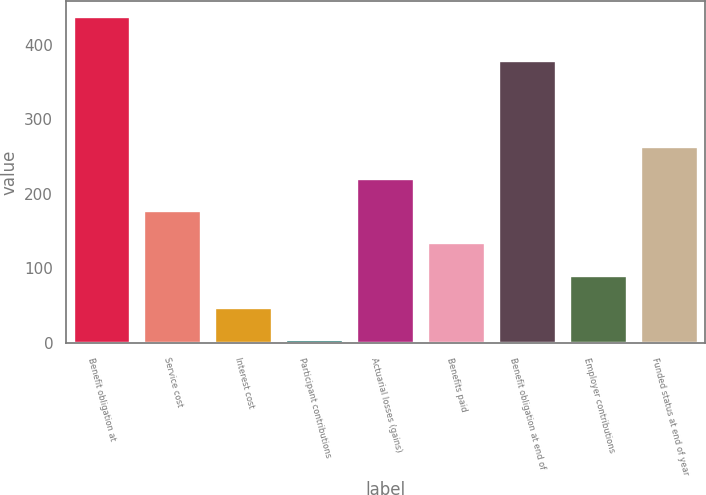<chart> <loc_0><loc_0><loc_500><loc_500><bar_chart><fcel>Benefit obligation at<fcel>Service cost<fcel>Interest cost<fcel>Participant contributions<fcel>Actuarial losses (gains)<fcel>Benefits paid<fcel>Benefit obligation at end of<fcel>Employer contributions<fcel>Funded status at end of year<nl><fcel>436.9<fcel>176.98<fcel>47.02<fcel>3.7<fcel>220.3<fcel>133.66<fcel>378.9<fcel>90.34<fcel>263.62<nl></chart> 